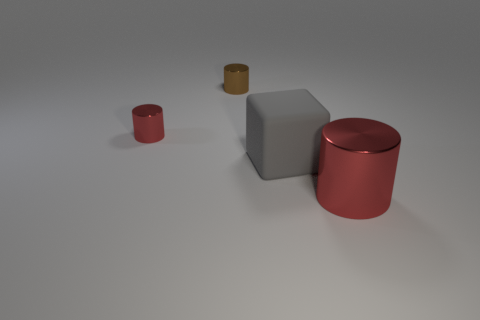How big is the red metal cylinder to the left of the red object that is to the right of the tiny cylinder to the left of the small brown shiny thing?
Offer a terse response. Small. Is the gray thing the same size as the brown shiny cylinder?
Your answer should be compact. No. How many things are small brown shiny cylinders or large shiny things?
Offer a very short reply. 2. How big is the red shiny cylinder to the left of the metal thing that is right of the large matte cube?
Ensure brevity in your answer.  Small. What size is the matte block?
Provide a short and direct response. Large. There is a thing that is both in front of the brown metallic cylinder and to the left of the gray matte object; what is its shape?
Give a very brief answer. Cylinder. There is a big object that is the same shape as the small red object; what color is it?
Keep it short and to the point. Red. What number of objects are red things behind the gray cube or metal cylinders that are on the right side of the tiny red cylinder?
Your answer should be very brief. 3. There is a large red metal thing; what shape is it?
Your answer should be very brief. Cylinder. How many red cylinders have the same material as the small brown object?
Your response must be concise. 2. 